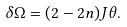<formula> <loc_0><loc_0><loc_500><loc_500>\delta \Omega = ( 2 - 2 n ) J \theta .</formula> 